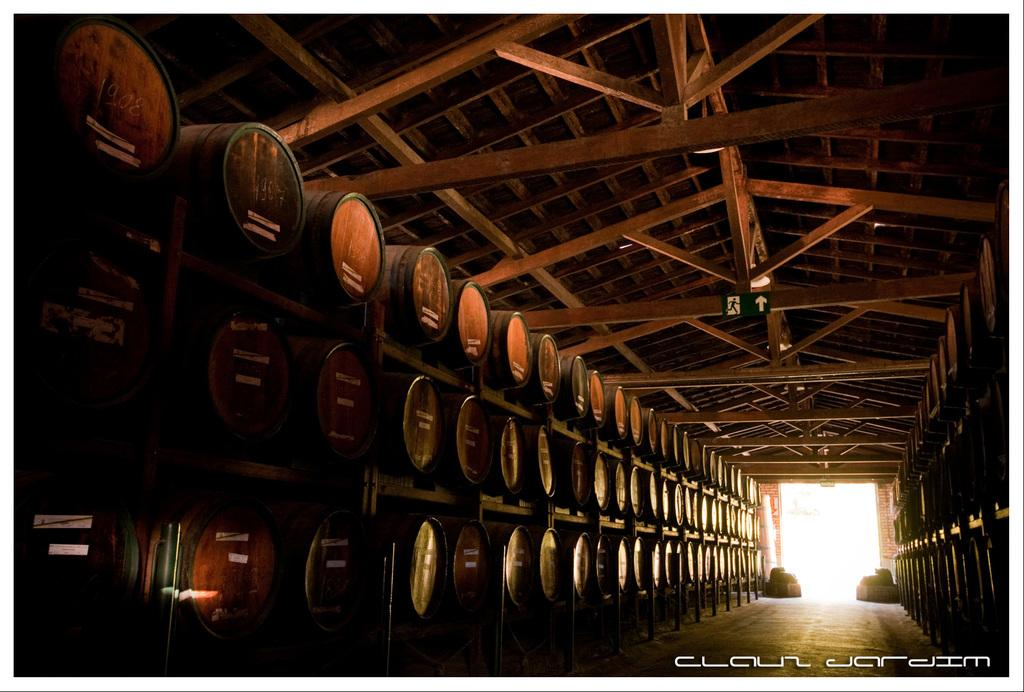What objects are placed in racks in the image? There are barrels placed in racks in the image. Where is the door located in the image? The door is on the right side of the image. What is visible at the top of the image? There is a roof visible at the top of the image. What type of juice is being squeezed by the minister in the image? There is no minister or juice present in the image; it features barrels placed in racks and a door on the right side. How does the roof blow away in the image? The roof does not blow away in the image; it is stationary and visible at the top of the image. 